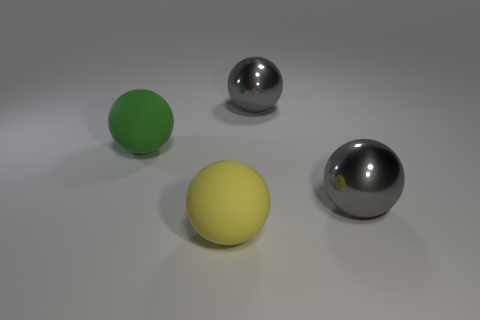Subtract all green matte spheres. How many spheres are left? 3 Subtract all purple cylinders. How many gray spheres are left? 2 Subtract all yellow balls. How many balls are left? 3 Add 4 yellow rubber cylinders. How many objects exist? 8 Subtract all yellow spheres. Subtract all yellow cubes. How many spheres are left? 3 Subtract all large purple shiny cylinders. Subtract all big gray objects. How many objects are left? 2 Add 1 big green spheres. How many big green spheres are left? 2 Add 1 green things. How many green things exist? 2 Subtract 0 purple balls. How many objects are left? 4 